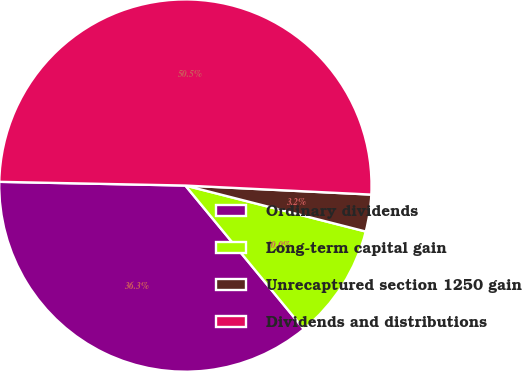Convert chart to OTSL. <chart><loc_0><loc_0><loc_500><loc_500><pie_chart><fcel>Ordinary dividends<fcel>Long-term capital gain<fcel>Unrecaptured section 1250 gain<fcel>Dividends and distributions<nl><fcel>36.3%<fcel>10.05%<fcel>3.2%<fcel>50.46%<nl></chart> 